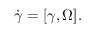<formula> <loc_0><loc_0><loc_500><loc_500>\begin{array} { r } { \dot { \boldsymbol \gamma } = [ { \boldsymbol \gamma } , { \boldsymbol \Omega } ] . } \end{array}</formula> 